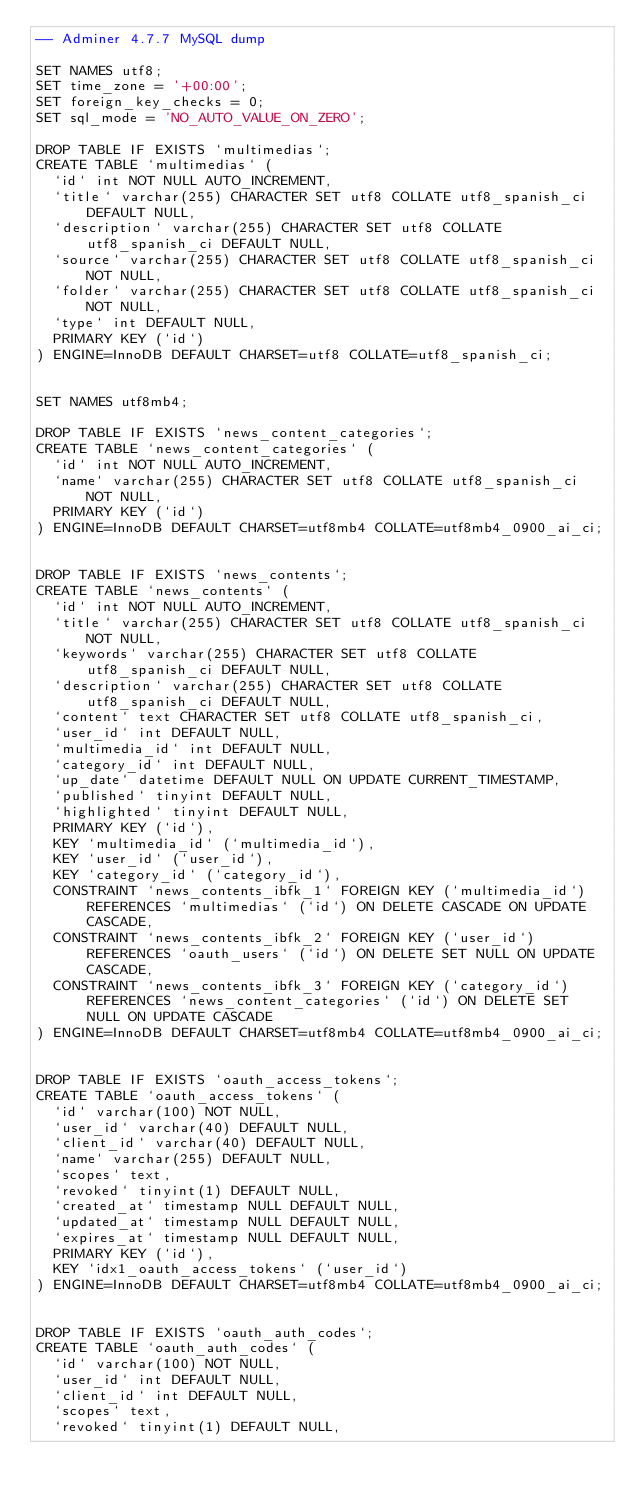Convert code to text. <code><loc_0><loc_0><loc_500><loc_500><_SQL_>-- Adminer 4.7.7 MySQL dump

SET NAMES utf8;
SET time_zone = '+00:00';
SET foreign_key_checks = 0;
SET sql_mode = 'NO_AUTO_VALUE_ON_ZERO';

DROP TABLE IF EXISTS `multimedias`;
CREATE TABLE `multimedias` (
  `id` int NOT NULL AUTO_INCREMENT,
  `title` varchar(255) CHARACTER SET utf8 COLLATE utf8_spanish_ci DEFAULT NULL,
  `description` varchar(255) CHARACTER SET utf8 COLLATE utf8_spanish_ci DEFAULT NULL,
  `source` varchar(255) CHARACTER SET utf8 COLLATE utf8_spanish_ci NOT NULL,
  `folder` varchar(255) CHARACTER SET utf8 COLLATE utf8_spanish_ci NOT NULL,
  `type` int DEFAULT NULL,
  PRIMARY KEY (`id`)
) ENGINE=InnoDB DEFAULT CHARSET=utf8 COLLATE=utf8_spanish_ci;


SET NAMES utf8mb4;

DROP TABLE IF EXISTS `news_content_categories`;
CREATE TABLE `news_content_categories` (
  `id` int NOT NULL AUTO_INCREMENT,
  `name` varchar(255) CHARACTER SET utf8 COLLATE utf8_spanish_ci NOT NULL,
  PRIMARY KEY (`id`)
) ENGINE=InnoDB DEFAULT CHARSET=utf8mb4 COLLATE=utf8mb4_0900_ai_ci;


DROP TABLE IF EXISTS `news_contents`;
CREATE TABLE `news_contents` (
  `id` int NOT NULL AUTO_INCREMENT,
  `title` varchar(255) CHARACTER SET utf8 COLLATE utf8_spanish_ci NOT NULL,
  `keywords` varchar(255) CHARACTER SET utf8 COLLATE utf8_spanish_ci DEFAULT NULL,
  `description` varchar(255) CHARACTER SET utf8 COLLATE utf8_spanish_ci DEFAULT NULL,
  `content` text CHARACTER SET utf8 COLLATE utf8_spanish_ci,
  `user_id` int DEFAULT NULL,
  `multimedia_id` int DEFAULT NULL,
  `category_id` int DEFAULT NULL,
  `up_date` datetime DEFAULT NULL ON UPDATE CURRENT_TIMESTAMP,
  `published` tinyint DEFAULT NULL,
  `highlighted` tinyint DEFAULT NULL,
  PRIMARY KEY (`id`),
  KEY `multimedia_id` (`multimedia_id`),
  KEY `user_id` (`user_id`),
  KEY `category_id` (`category_id`),
  CONSTRAINT `news_contents_ibfk_1` FOREIGN KEY (`multimedia_id`) REFERENCES `multimedias` (`id`) ON DELETE CASCADE ON UPDATE CASCADE,
  CONSTRAINT `news_contents_ibfk_2` FOREIGN KEY (`user_id`) REFERENCES `oauth_users` (`id`) ON DELETE SET NULL ON UPDATE CASCADE,
  CONSTRAINT `news_contents_ibfk_3` FOREIGN KEY (`category_id`) REFERENCES `news_content_categories` (`id`) ON DELETE SET NULL ON UPDATE CASCADE
) ENGINE=InnoDB DEFAULT CHARSET=utf8mb4 COLLATE=utf8mb4_0900_ai_ci;


DROP TABLE IF EXISTS `oauth_access_tokens`;
CREATE TABLE `oauth_access_tokens` (
  `id` varchar(100) NOT NULL,
  `user_id` varchar(40) DEFAULT NULL,
  `client_id` varchar(40) DEFAULT NULL,
  `name` varchar(255) DEFAULT NULL,
  `scopes` text,
  `revoked` tinyint(1) DEFAULT NULL,
  `created_at` timestamp NULL DEFAULT NULL,
  `updated_at` timestamp NULL DEFAULT NULL,
  `expires_at` timestamp NULL DEFAULT NULL,
  PRIMARY KEY (`id`),
  KEY `idx1_oauth_access_tokens` (`user_id`)
) ENGINE=InnoDB DEFAULT CHARSET=utf8mb4 COLLATE=utf8mb4_0900_ai_ci;


DROP TABLE IF EXISTS `oauth_auth_codes`;
CREATE TABLE `oauth_auth_codes` (
  `id` varchar(100) NOT NULL,
  `user_id` int DEFAULT NULL,
  `client_id` int DEFAULT NULL,
  `scopes` text,
  `revoked` tinyint(1) DEFAULT NULL,</code> 